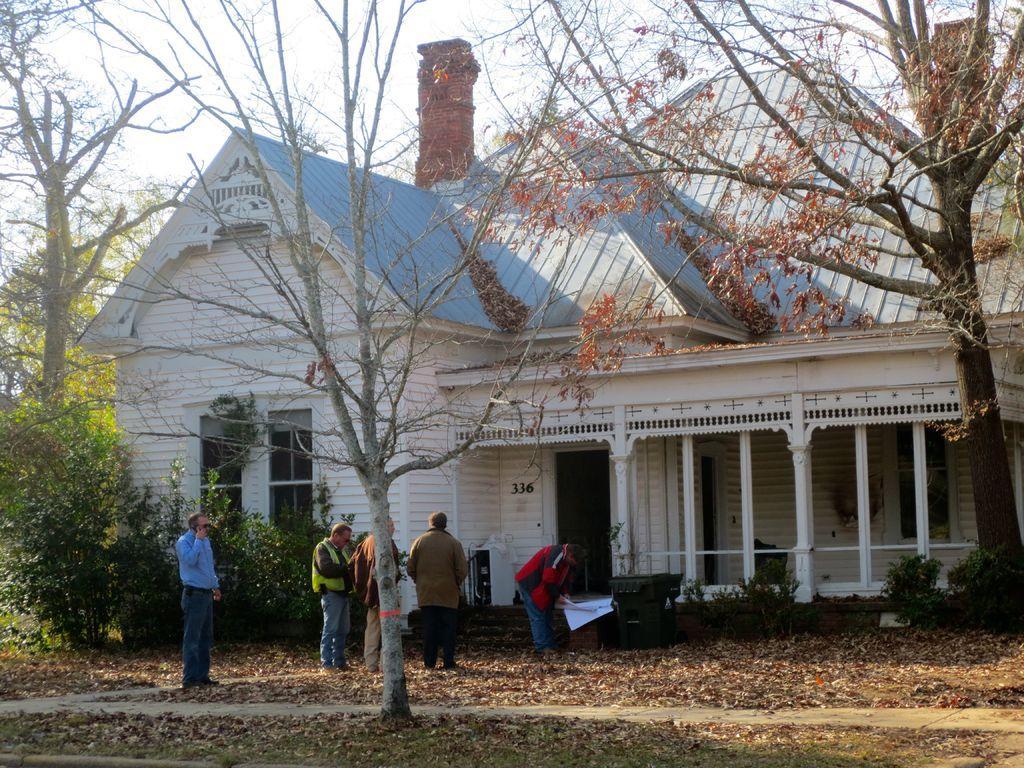In one or two sentences, can you explain what this image depicts? In this image, we can see a building with chimney and in the background, there are trees, plants and people and one of them is holding some papers. At the bottom, there is ground covered with leaves and at the top, there is sky. 